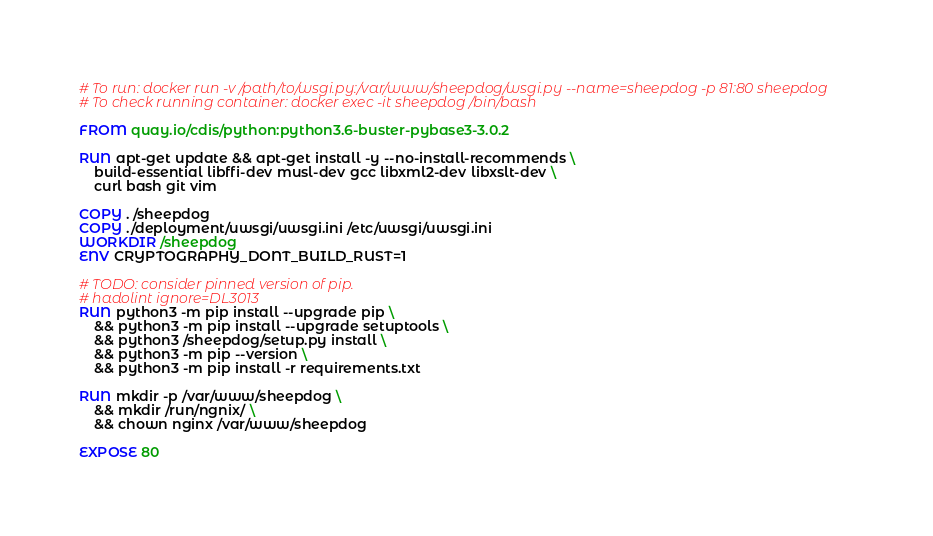<code> <loc_0><loc_0><loc_500><loc_500><_Dockerfile_># To run: docker run -v /path/to/wsgi.py:/var/www/sheepdog/wsgi.py --name=sheepdog -p 81:80 sheepdog
# To check running container: docker exec -it sheepdog /bin/bash

FROM quay.io/cdis/python:python3.6-buster-pybase3-3.0.2

RUN apt-get update && apt-get install -y --no-install-recommends \
    build-essential libffi-dev musl-dev gcc libxml2-dev libxslt-dev \
    curl bash git vim

COPY . /sheepdog
COPY ./deployment/uwsgi/uwsgi.ini /etc/uwsgi/uwsgi.ini
WORKDIR /sheepdog
ENV CRYPTOGRAPHY_DONT_BUILD_RUST=1

# TODO: consider pinned version of pip.
# hadolint ignore=DL3013
RUN python3 -m pip install --upgrade pip \
    && python3 -m pip install --upgrade setuptools \
    && python3 /sheepdog/setup.py install \
    && python3 -m pip --version \
    && python3 -m pip install -r requirements.txt

RUN mkdir -p /var/www/sheepdog \
    && mkdir /run/ngnix/ \
    && chown nginx /var/www/sheepdog

EXPOSE 80
</code> 